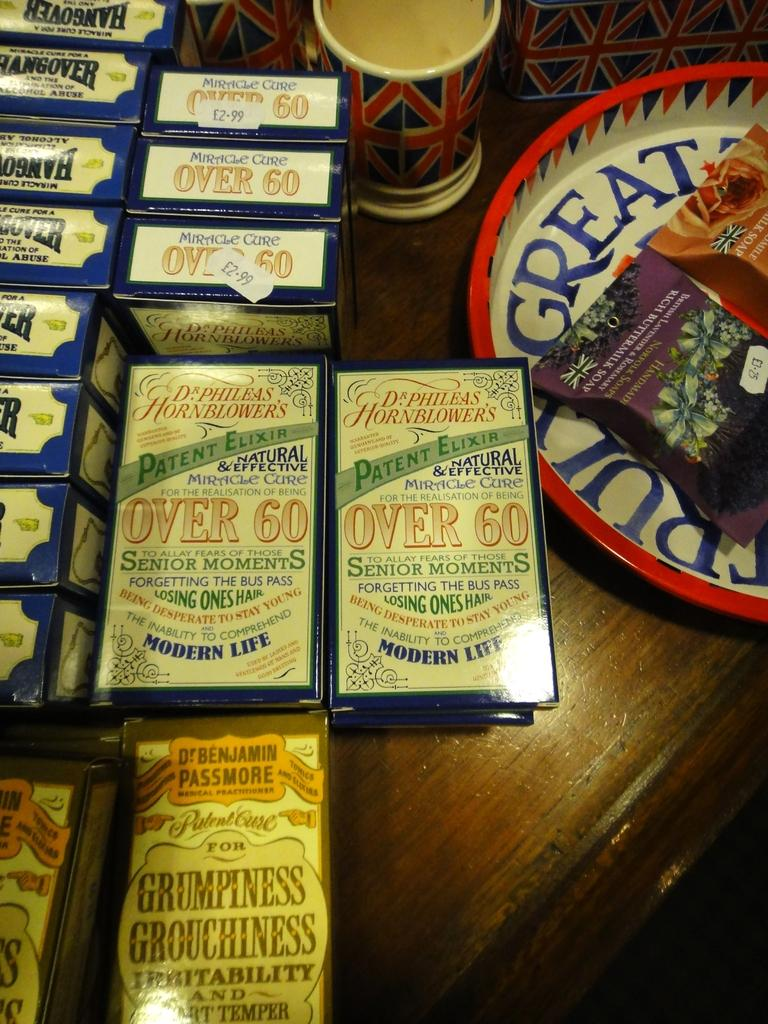<image>
Give a short and clear explanation of the subsequent image. For 2.99 pounds one can buy an elixir for seniors. 